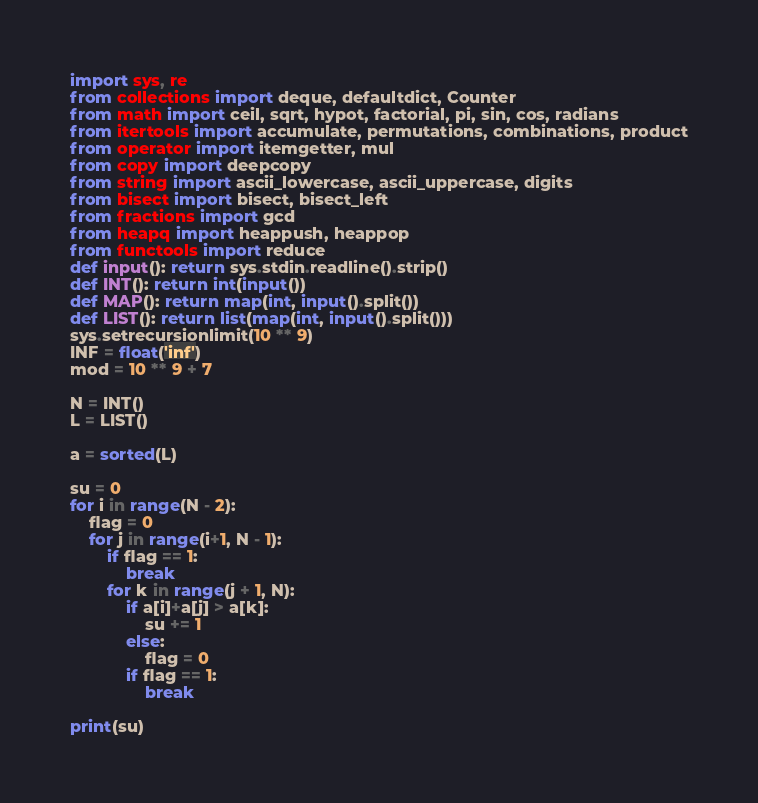<code> <loc_0><loc_0><loc_500><loc_500><_Python_>import sys, re
from collections import deque, defaultdict, Counter
from math import ceil, sqrt, hypot, factorial, pi, sin, cos, radians
from itertools import accumulate, permutations, combinations, product
from operator import itemgetter, mul
from copy import deepcopy
from string import ascii_lowercase, ascii_uppercase, digits
from bisect import bisect, bisect_left
from fractions import gcd
from heapq import heappush, heappop
from functools import reduce
def input(): return sys.stdin.readline().strip()
def INT(): return int(input())
def MAP(): return map(int, input().split())
def LIST(): return list(map(int, input().split()))
sys.setrecursionlimit(10 ** 9)
INF = float('inf')
mod = 10 ** 9 + 7

N = INT()
L = LIST()

a = sorted(L)

su = 0
for i in range(N - 2):
	flag = 0
	for j in range(i+1, N - 1):
		if flag == 1:
			break
		for k in range(j + 1, N):
			if a[i]+a[j] > a[k]:
				su += 1
			else:
				flag = 0
			if flag == 1:
				break

print(su)</code> 